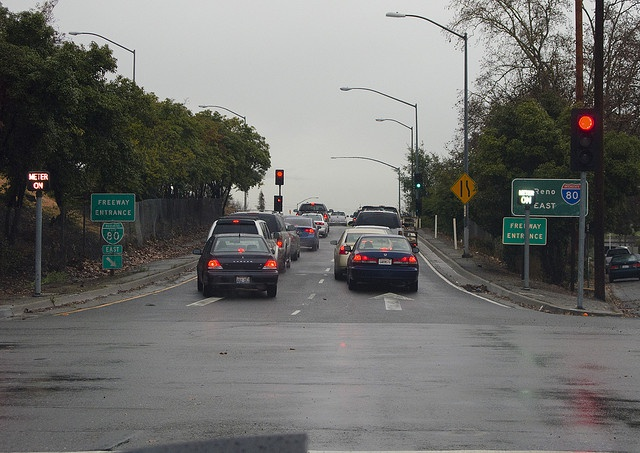Describe the objects in this image and their specific colors. I can see car in lightgray, black, gray, and darkgray tones, car in lightgray, black, darkgray, and gray tones, traffic light in lightgray, black, maroon, and red tones, car in lightgray, black, gray, and darkgray tones, and car in lightgray, black, gray, and darkgray tones in this image. 